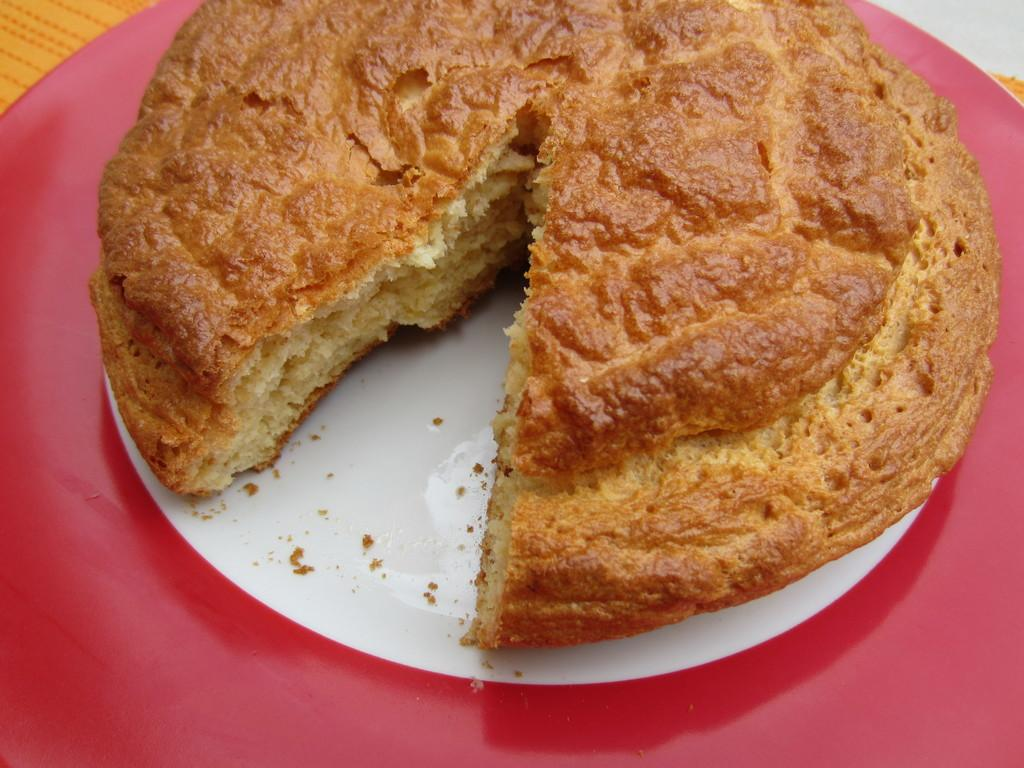What is on the plate that is visible in the image? There is a cake on the plate in the image. What color is the plate? The plate is white. What is the color of the surface the plate is on? The plate is on a red surface. How many screws can be seen holding the cake together in the image? There are no screws visible in the image, as screws are not used to hold cakes together. 